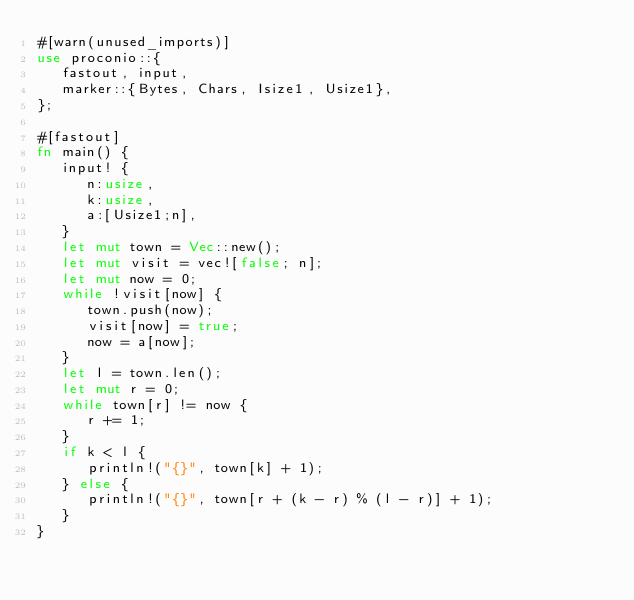Convert code to text. <code><loc_0><loc_0><loc_500><loc_500><_Rust_>#[warn(unused_imports)]
use proconio::{
   fastout, input,
   marker::{Bytes, Chars, Isize1, Usize1},
};

#[fastout]
fn main() {
   input! {
      n:usize,
      k:usize,
      a:[Usize1;n],
   }
   let mut town = Vec::new();
   let mut visit = vec![false; n];
   let mut now = 0;
   while !visit[now] {
      town.push(now);
      visit[now] = true;
      now = a[now];
   }
   let l = town.len();
   let mut r = 0;
   while town[r] != now {
      r += 1;
   }
   if k < l {
      println!("{}", town[k] + 1);
   } else {
      println!("{}", town[r + (k - r) % (l - r)] + 1);
   }
}
</code> 